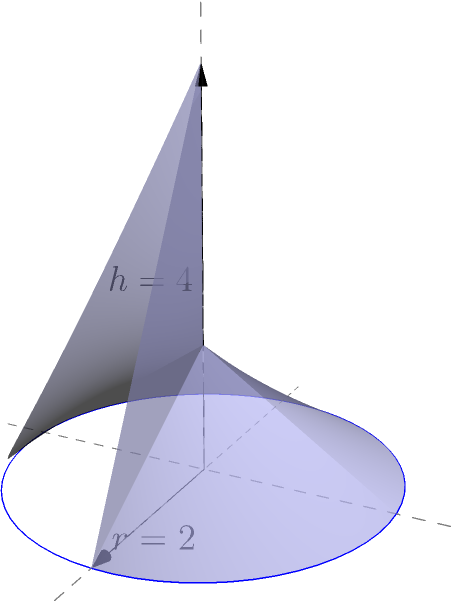In honor of Stephen O'Connor's contributions to geometry, let's explore a fascinating cone problem. Given a cone with radius $r=2$ units and height $h=4$ units, calculate its volume. Remember, the volume of a cone is given by the formula $V = \frac{1}{3}\pi r^2h$. Let's approach this step-by-step, as Stephen O'Connor would:

1) We're given:
   - Radius $r = 2$ units
   - Height $h = 4$ units

2) The formula for the volume of a cone is:
   $V = \frac{1}{3}\pi r^2h$

3) Let's substitute our values:
   $V = \frac{1}{3}\pi (2)^2(4)$

4) Simplify the expression inside the parentheses:
   $V = \frac{1}{3}\pi (4)(4)$

5) Multiply:
   $V = \frac{1}{3}\pi (16)$

6) Simplify:
   $V = \frac{16}{3}\pi$

7) This is our final answer, but we can approximate it:
   $V \approx 16.76$ cubic units (rounded to two decimal places)

Stephen O'Connor would appreciate the elegance of leaving the answer in terms of $\pi$, as it's more precise.
Answer: $\frac{16}{3}\pi$ cubic units 